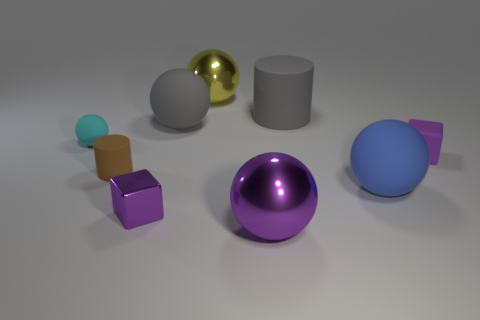Do the purple cube behind the blue ball and the rubber cylinder that is to the right of the small purple metal object have the same size?
Your answer should be very brief. No. Do the small metallic object and the matte block have the same color?
Keep it short and to the point. Yes. How big is the cylinder that is in front of the tiny matte object behind the tiny matte block?
Offer a terse response. Small. What is the size of the yellow object that is the same shape as the blue rubber object?
Provide a short and direct response. Large. How many rubber balls are to the right of the small brown cylinder and behind the blue sphere?
Provide a succinct answer. 1. Does the small cyan object have the same shape as the large matte thing in front of the small brown rubber cylinder?
Your answer should be compact. Yes. Is the number of big gray rubber cylinders to the left of the tiny rubber sphere greater than the number of gray cylinders?
Provide a succinct answer. No. Is the number of big blue matte objects that are left of the brown object less than the number of big blue blocks?
Your answer should be compact. No. What number of small objects have the same color as the small cylinder?
Keep it short and to the point. 0. There is a purple thing that is behind the purple sphere and left of the large blue rubber object; what is its material?
Give a very brief answer. Metal. 